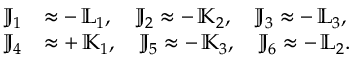<formula> <loc_0><loc_0><loc_500><loc_500>\begin{array} { r l } { { \mathbb { J } } _ { 1 } } & { \approx - \, { \mathbb { L } } _ { 1 } , \quad \mathbb { J } _ { 2 } \approx - \, { \mathbb { K } } _ { 2 } , \quad \mathbb { J } _ { 3 } \approx - \, { \mathbb { L } } _ { 3 } , } \\ { { \mathbb { J } } _ { 4 } } & { \approx + \, { \mathbb { K } } _ { 1 } , \quad \mathbb { J } _ { 5 } \approx - \, { \mathbb { K } } _ { 3 } , \quad \mathbb { J } _ { 6 } \approx - \, { \mathbb { L } } _ { 2 } . } \end{array}</formula> 